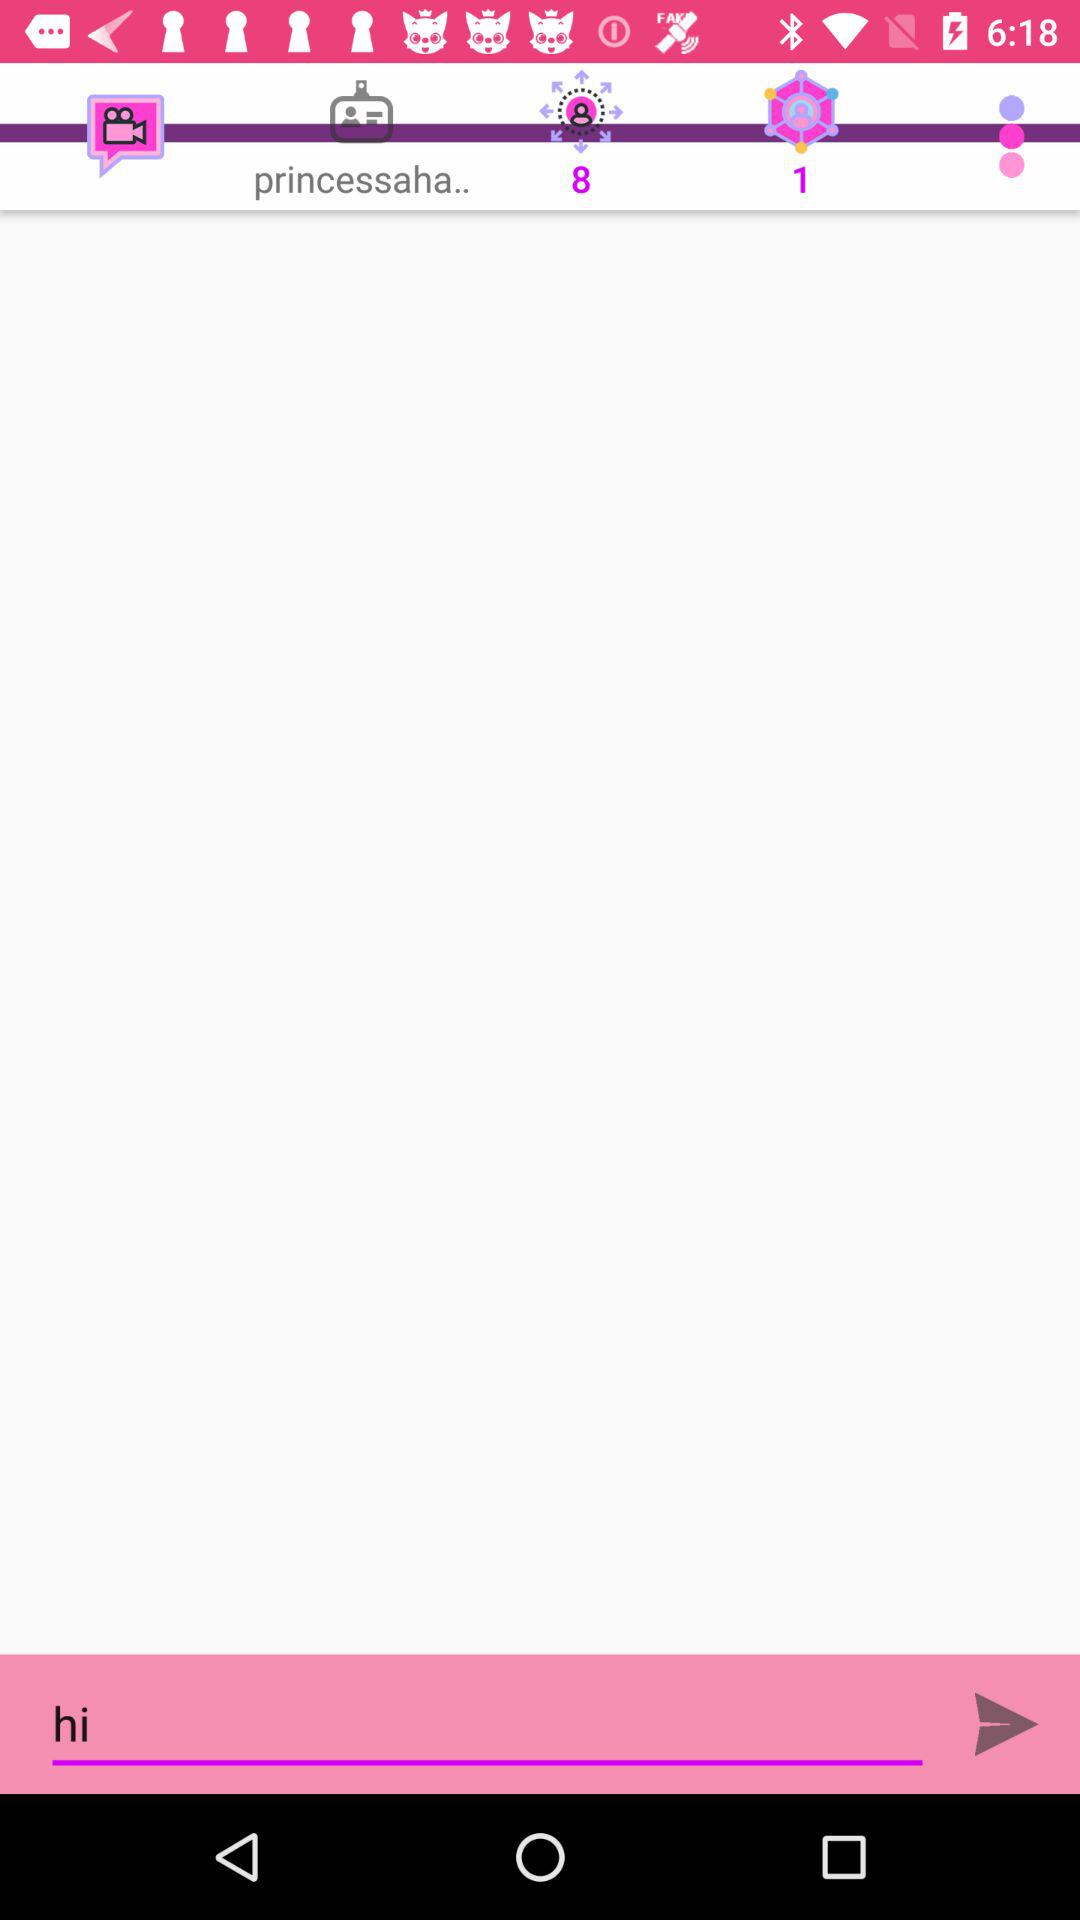What time was the message sent?
When the provided information is insufficient, respond with <no answer>. <no answer> 